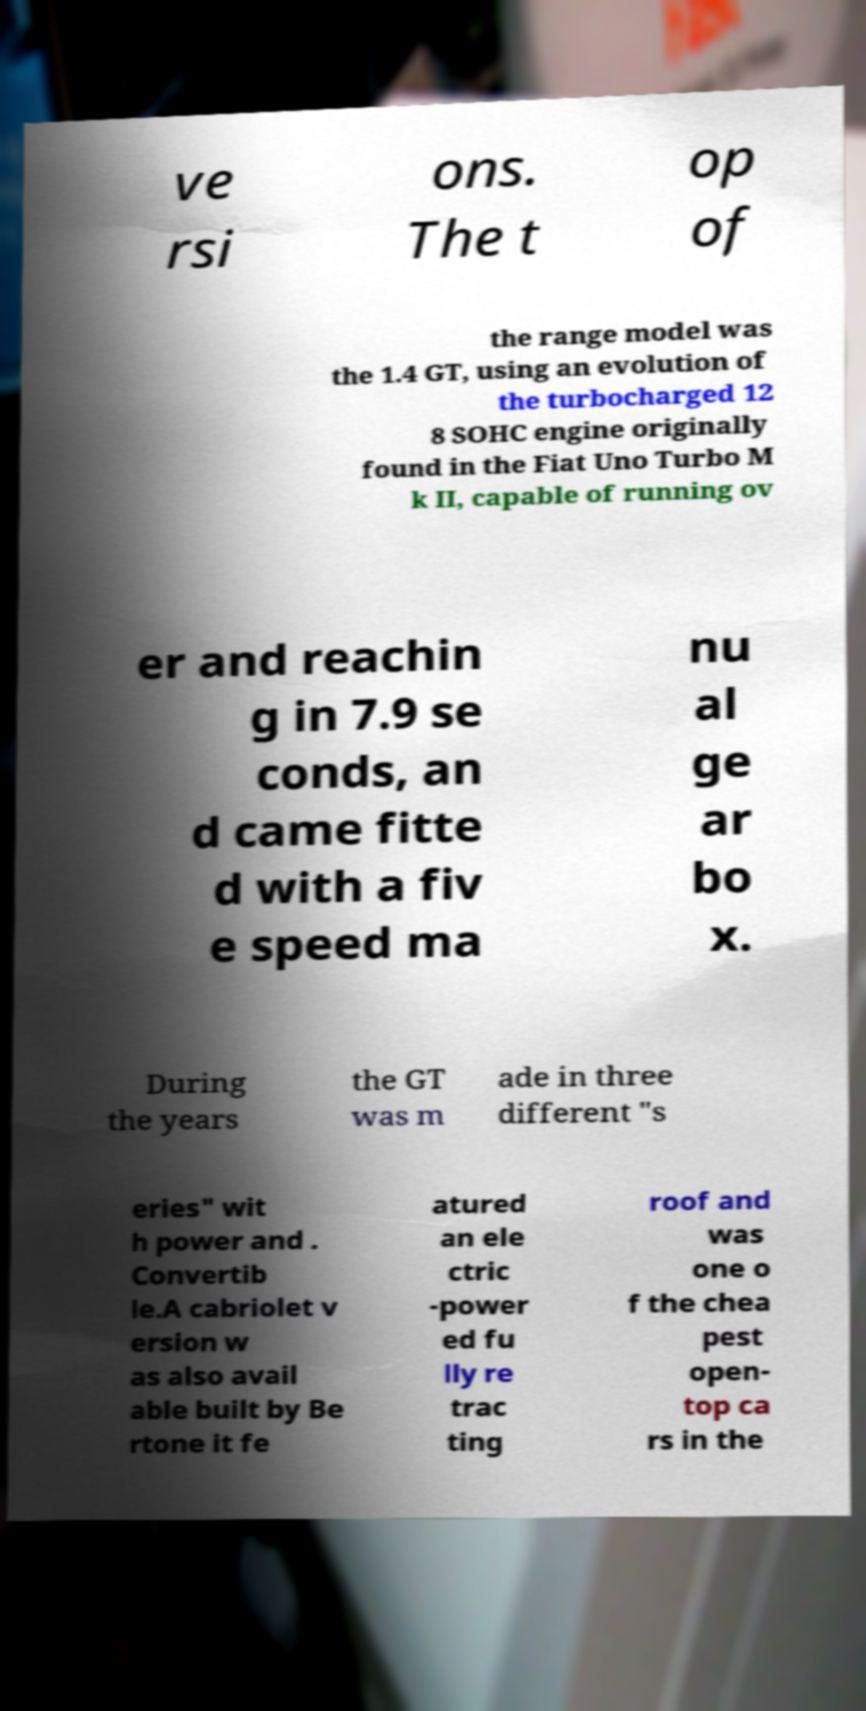I need the written content from this picture converted into text. Can you do that? ve rsi ons. The t op of the range model was the 1.4 GT, using an evolution of the turbocharged 12 8 SOHC engine originally found in the Fiat Uno Turbo M k II, capable of running ov er and reachin g in 7.9 se conds, an d came fitte d with a fiv e speed ma nu al ge ar bo x. During the years the GT was m ade in three different "s eries" wit h power and . Convertib le.A cabriolet v ersion w as also avail able built by Be rtone it fe atured an ele ctric -power ed fu lly re trac ting roof and was one o f the chea pest open- top ca rs in the 